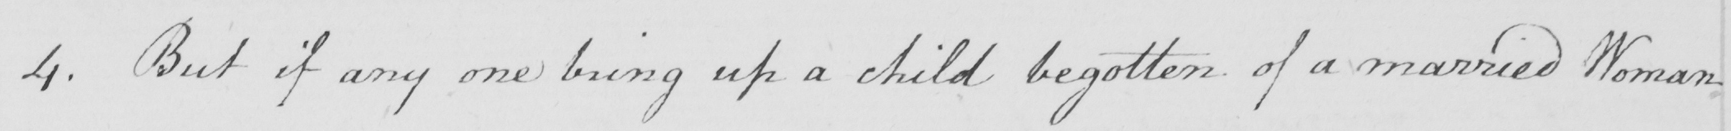What text is written in this handwritten line? 4 . But if any one bring up a child begotten of a married Woman 